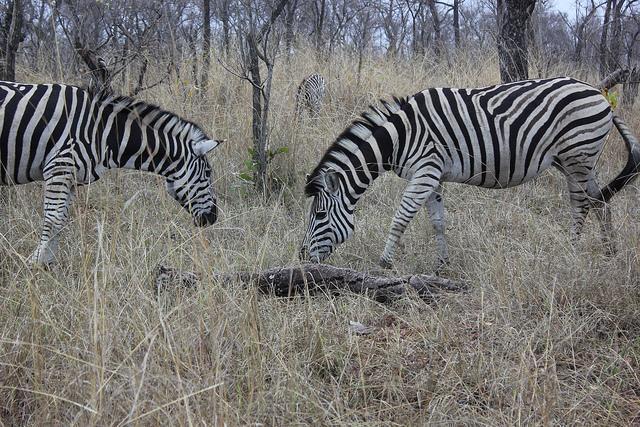What matches the color scheme of the animals?
Select the correct answer and articulate reasoning with the following format: 'Answer: answer
Rationale: rationale.'
Options: Piano keys, lime, pumpkin, cherry. Answer: piano keys.
Rationale: The colors are like keys. 